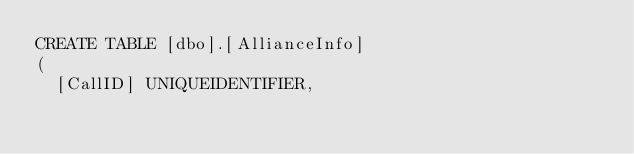<code> <loc_0><loc_0><loc_500><loc_500><_SQL_>CREATE TABLE [dbo].[AllianceInfo]
(
	[CallID] UNIQUEIDENTIFIER,</code> 